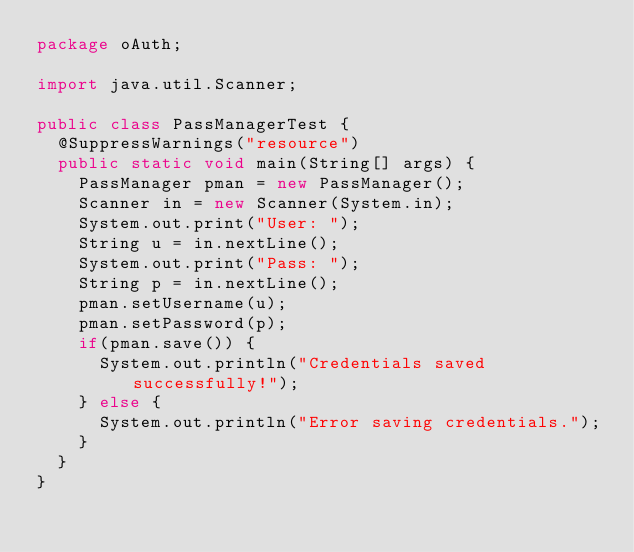<code> <loc_0><loc_0><loc_500><loc_500><_Java_>package oAuth;

import java.util.Scanner;

public class PassManagerTest {
	@SuppressWarnings("resource")
	public static void main(String[] args) {
		PassManager pman = new PassManager();
		Scanner in = new Scanner(System.in);
		System.out.print("User: ");
		String u = in.nextLine();
		System.out.print("Pass: ");
		String p = in.nextLine();
		pman.setUsername(u);
		pman.setPassword(p);
		if(pman.save()) {
			System.out.println("Credentials saved successfully!");
		} else {
			System.out.println("Error saving credentials.");
		}
	}
}
</code> 